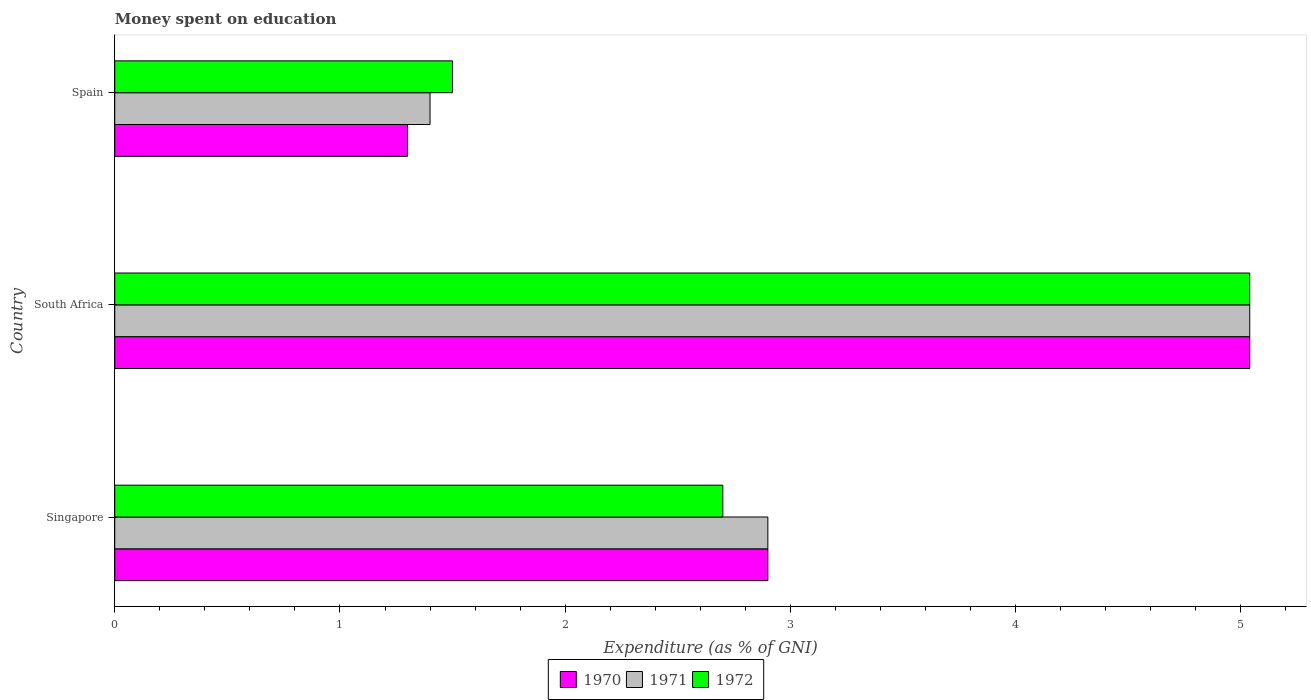How many different coloured bars are there?
Keep it short and to the point. 3. Are the number of bars on each tick of the Y-axis equal?
Make the answer very short. Yes. How many bars are there on the 2nd tick from the top?
Your answer should be very brief. 3. In how many cases, is the number of bars for a given country not equal to the number of legend labels?
Offer a very short reply. 0. Across all countries, what is the maximum amount of money spent on education in 1971?
Keep it short and to the point. 5.04. In which country was the amount of money spent on education in 1970 maximum?
Make the answer very short. South Africa. In which country was the amount of money spent on education in 1972 minimum?
Offer a terse response. Spain. What is the total amount of money spent on education in 1970 in the graph?
Make the answer very short. 9.24. What is the difference between the amount of money spent on education in 1970 in Singapore and that in South Africa?
Offer a terse response. -2.14. What is the difference between the amount of money spent on education in 1971 in Spain and the amount of money spent on education in 1970 in Singapore?
Keep it short and to the point. -1.5. What is the average amount of money spent on education in 1971 per country?
Keep it short and to the point. 3.11. What is the difference between the amount of money spent on education in 1971 and amount of money spent on education in 1970 in South Africa?
Your answer should be compact. 0. In how many countries, is the amount of money spent on education in 1970 greater than 3.2 %?
Ensure brevity in your answer.  1. What is the ratio of the amount of money spent on education in 1970 in Singapore to that in Spain?
Offer a terse response. 2.23. Is the difference between the amount of money spent on education in 1971 in Singapore and South Africa greater than the difference between the amount of money spent on education in 1970 in Singapore and South Africa?
Provide a short and direct response. No. What is the difference between the highest and the second highest amount of money spent on education in 1972?
Provide a succinct answer. 2.34. What is the difference between the highest and the lowest amount of money spent on education in 1970?
Provide a succinct answer. 3.74. What does the 3rd bar from the top in Singapore represents?
Offer a terse response. 1970. Is it the case that in every country, the sum of the amount of money spent on education in 1970 and amount of money spent on education in 1971 is greater than the amount of money spent on education in 1972?
Provide a succinct answer. Yes. Are all the bars in the graph horizontal?
Provide a succinct answer. Yes. Are the values on the major ticks of X-axis written in scientific E-notation?
Ensure brevity in your answer.  No. Does the graph contain any zero values?
Ensure brevity in your answer.  No. Does the graph contain grids?
Make the answer very short. No. How many legend labels are there?
Provide a short and direct response. 3. How are the legend labels stacked?
Provide a short and direct response. Horizontal. What is the title of the graph?
Give a very brief answer. Money spent on education. Does "1970" appear as one of the legend labels in the graph?
Your response must be concise. Yes. What is the label or title of the X-axis?
Provide a short and direct response. Expenditure (as % of GNI). What is the Expenditure (as % of GNI) of 1970 in Singapore?
Ensure brevity in your answer.  2.9. What is the Expenditure (as % of GNI) of 1972 in Singapore?
Your answer should be compact. 2.7. What is the Expenditure (as % of GNI) in 1970 in South Africa?
Keep it short and to the point. 5.04. What is the Expenditure (as % of GNI) in 1971 in South Africa?
Keep it short and to the point. 5.04. What is the Expenditure (as % of GNI) in 1972 in South Africa?
Ensure brevity in your answer.  5.04. What is the Expenditure (as % of GNI) in 1971 in Spain?
Your response must be concise. 1.4. What is the Expenditure (as % of GNI) of 1972 in Spain?
Your answer should be compact. 1.5. Across all countries, what is the maximum Expenditure (as % of GNI) of 1970?
Your answer should be compact. 5.04. Across all countries, what is the maximum Expenditure (as % of GNI) in 1971?
Provide a succinct answer. 5.04. Across all countries, what is the maximum Expenditure (as % of GNI) of 1972?
Keep it short and to the point. 5.04. Across all countries, what is the minimum Expenditure (as % of GNI) in 1970?
Keep it short and to the point. 1.3. Across all countries, what is the minimum Expenditure (as % of GNI) in 1971?
Offer a terse response. 1.4. Across all countries, what is the minimum Expenditure (as % of GNI) of 1972?
Keep it short and to the point. 1.5. What is the total Expenditure (as % of GNI) in 1970 in the graph?
Offer a terse response. 9.24. What is the total Expenditure (as % of GNI) in 1971 in the graph?
Your answer should be very brief. 9.34. What is the total Expenditure (as % of GNI) in 1972 in the graph?
Your answer should be compact. 9.24. What is the difference between the Expenditure (as % of GNI) in 1970 in Singapore and that in South Africa?
Ensure brevity in your answer.  -2.14. What is the difference between the Expenditure (as % of GNI) in 1971 in Singapore and that in South Africa?
Offer a very short reply. -2.14. What is the difference between the Expenditure (as % of GNI) in 1972 in Singapore and that in South Africa?
Provide a short and direct response. -2.34. What is the difference between the Expenditure (as % of GNI) of 1972 in Singapore and that in Spain?
Keep it short and to the point. 1.2. What is the difference between the Expenditure (as % of GNI) in 1970 in South Africa and that in Spain?
Give a very brief answer. 3.74. What is the difference between the Expenditure (as % of GNI) in 1971 in South Africa and that in Spain?
Offer a very short reply. 3.64. What is the difference between the Expenditure (as % of GNI) of 1972 in South Africa and that in Spain?
Keep it short and to the point. 3.54. What is the difference between the Expenditure (as % of GNI) in 1970 in Singapore and the Expenditure (as % of GNI) in 1971 in South Africa?
Provide a short and direct response. -2.14. What is the difference between the Expenditure (as % of GNI) of 1970 in Singapore and the Expenditure (as % of GNI) of 1972 in South Africa?
Your response must be concise. -2.14. What is the difference between the Expenditure (as % of GNI) in 1971 in Singapore and the Expenditure (as % of GNI) in 1972 in South Africa?
Your answer should be compact. -2.14. What is the difference between the Expenditure (as % of GNI) in 1970 in Singapore and the Expenditure (as % of GNI) in 1972 in Spain?
Give a very brief answer. 1.4. What is the difference between the Expenditure (as % of GNI) of 1971 in Singapore and the Expenditure (as % of GNI) of 1972 in Spain?
Offer a very short reply. 1.4. What is the difference between the Expenditure (as % of GNI) of 1970 in South Africa and the Expenditure (as % of GNI) of 1971 in Spain?
Give a very brief answer. 3.64. What is the difference between the Expenditure (as % of GNI) of 1970 in South Africa and the Expenditure (as % of GNI) of 1972 in Spain?
Offer a terse response. 3.54. What is the difference between the Expenditure (as % of GNI) in 1971 in South Africa and the Expenditure (as % of GNI) in 1972 in Spain?
Make the answer very short. 3.54. What is the average Expenditure (as % of GNI) of 1970 per country?
Offer a very short reply. 3.08. What is the average Expenditure (as % of GNI) in 1971 per country?
Your response must be concise. 3.11. What is the average Expenditure (as % of GNI) in 1972 per country?
Your answer should be very brief. 3.08. What is the difference between the Expenditure (as % of GNI) of 1970 and Expenditure (as % of GNI) of 1971 in Singapore?
Your answer should be compact. 0. What is the difference between the Expenditure (as % of GNI) in 1970 and Expenditure (as % of GNI) in 1972 in Singapore?
Your answer should be very brief. 0.2. What is the difference between the Expenditure (as % of GNI) of 1971 and Expenditure (as % of GNI) of 1972 in Singapore?
Make the answer very short. 0.2. What is the difference between the Expenditure (as % of GNI) of 1970 and Expenditure (as % of GNI) of 1971 in South Africa?
Your response must be concise. 0. What is the ratio of the Expenditure (as % of GNI) of 1970 in Singapore to that in South Africa?
Make the answer very short. 0.58. What is the ratio of the Expenditure (as % of GNI) of 1971 in Singapore to that in South Africa?
Offer a very short reply. 0.58. What is the ratio of the Expenditure (as % of GNI) of 1972 in Singapore to that in South Africa?
Offer a terse response. 0.54. What is the ratio of the Expenditure (as % of GNI) of 1970 in Singapore to that in Spain?
Your answer should be very brief. 2.23. What is the ratio of the Expenditure (as % of GNI) of 1971 in Singapore to that in Spain?
Ensure brevity in your answer.  2.07. What is the ratio of the Expenditure (as % of GNI) in 1972 in Singapore to that in Spain?
Ensure brevity in your answer.  1.8. What is the ratio of the Expenditure (as % of GNI) in 1970 in South Africa to that in Spain?
Your answer should be compact. 3.88. What is the ratio of the Expenditure (as % of GNI) of 1971 in South Africa to that in Spain?
Give a very brief answer. 3.6. What is the ratio of the Expenditure (as % of GNI) of 1972 in South Africa to that in Spain?
Your response must be concise. 3.36. What is the difference between the highest and the second highest Expenditure (as % of GNI) in 1970?
Give a very brief answer. 2.14. What is the difference between the highest and the second highest Expenditure (as % of GNI) in 1971?
Offer a very short reply. 2.14. What is the difference between the highest and the second highest Expenditure (as % of GNI) in 1972?
Offer a very short reply. 2.34. What is the difference between the highest and the lowest Expenditure (as % of GNI) in 1970?
Provide a succinct answer. 3.74. What is the difference between the highest and the lowest Expenditure (as % of GNI) of 1971?
Keep it short and to the point. 3.64. What is the difference between the highest and the lowest Expenditure (as % of GNI) of 1972?
Make the answer very short. 3.54. 